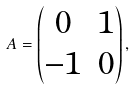<formula> <loc_0><loc_0><loc_500><loc_500>A = \left ( \begin{matrix} 0 & 1 \\ - 1 & 0 \end{matrix} \right ) ,</formula> 